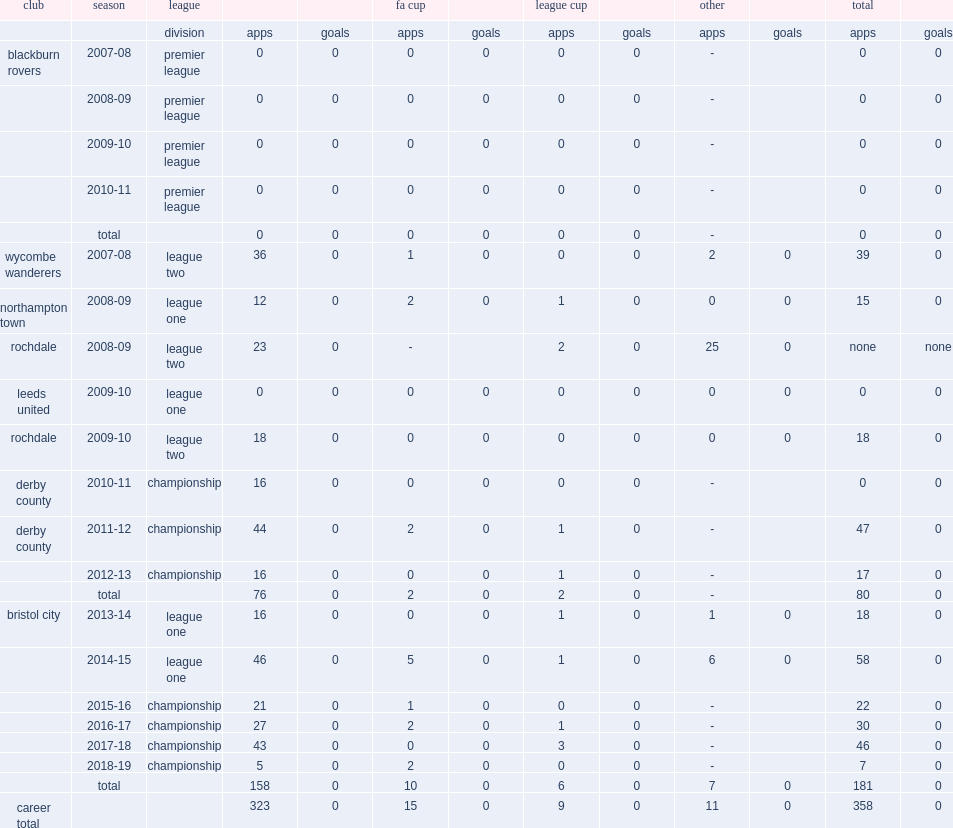In 2014-15, which league did fielding appear for bristol city? League one. 